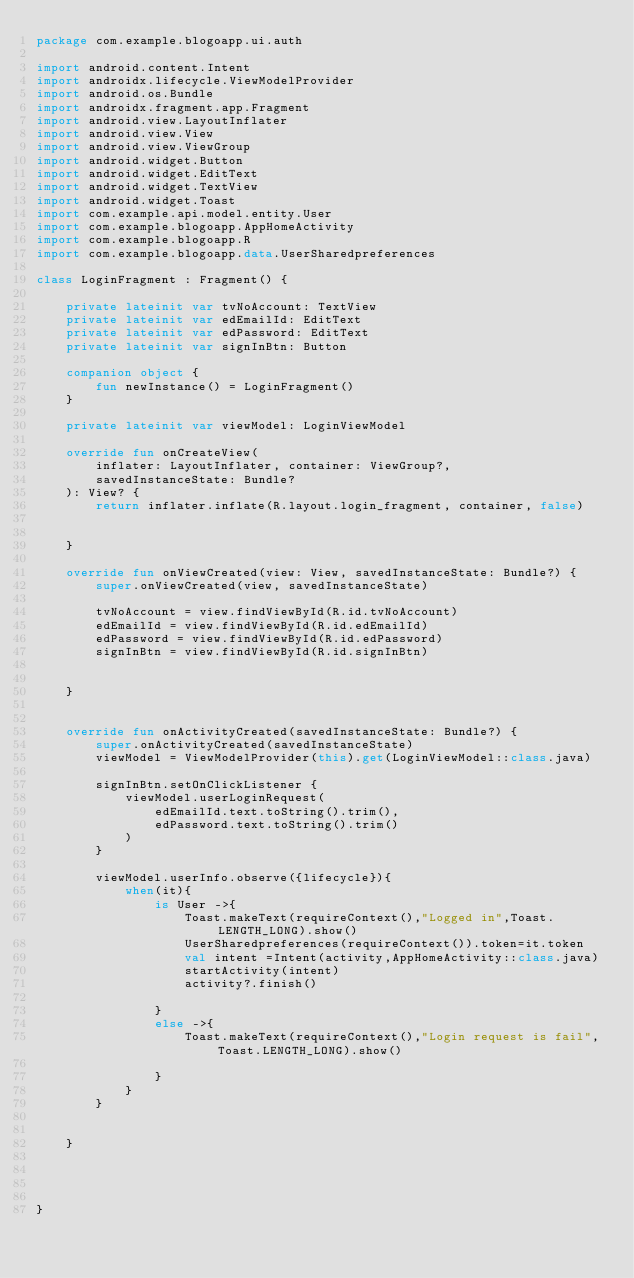<code> <loc_0><loc_0><loc_500><loc_500><_Kotlin_>package com.example.blogoapp.ui.auth

import android.content.Intent
import androidx.lifecycle.ViewModelProvider
import android.os.Bundle
import androidx.fragment.app.Fragment
import android.view.LayoutInflater
import android.view.View
import android.view.ViewGroup
import android.widget.Button
import android.widget.EditText
import android.widget.TextView
import android.widget.Toast
import com.example.api.model.entity.User
import com.example.blogoapp.AppHomeActivity
import com.example.blogoapp.R
import com.example.blogoapp.data.UserSharedpreferences

class LoginFragment : Fragment() {

    private lateinit var tvNoAccount: TextView
    private lateinit var edEmailId: EditText
    private lateinit var edPassword: EditText
    private lateinit var signInBtn: Button

    companion object {
        fun newInstance() = LoginFragment()
    }

    private lateinit var viewModel: LoginViewModel

    override fun onCreateView(
        inflater: LayoutInflater, container: ViewGroup?,
        savedInstanceState: Bundle?
    ): View? {
        return inflater.inflate(R.layout.login_fragment, container, false)


    }

    override fun onViewCreated(view: View, savedInstanceState: Bundle?) {
        super.onViewCreated(view, savedInstanceState)

        tvNoAccount = view.findViewById(R.id.tvNoAccount)
        edEmailId = view.findViewById(R.id.edEmailId)
        edPassword = view.findViewById(R.id.edPassword)
        signInBtn = view.findViewById(R.id.signInBtn)


    }


    override fun onActivityCreated(savedInstanceState: Bundle?) {
        super.onActivityCreated(savedInstanceState)
        viewModel = ViewModelProvider(this).get(LoginViewModel::class.java)

        signInBtn.setOnClickListener {
            viewModel.userLoginRequest(
                edEmailId.text.toString().trim(),
                edPassword.text.toString().trim()
            )
        }

        viewModel.userInfo.observe({lifecycle}){
            when(it){
                is User ->{
                    Toast.makeText(requireContext(),"Logged in",Toast.LENGTH_LONG).show()
                    UserSharedpreferences(requireContext()).token=it.token
                    val intent =Intent(activity,AppHomeActivity::class.java)
                    startActivity(intent)
                    activity?.finish()

                }
                else ->{
                    Toast.makeText(requireContext(),"Login request is fail",Toast.LENGTH_LONG).show()

                }
            }
        }


    }




}</code> 